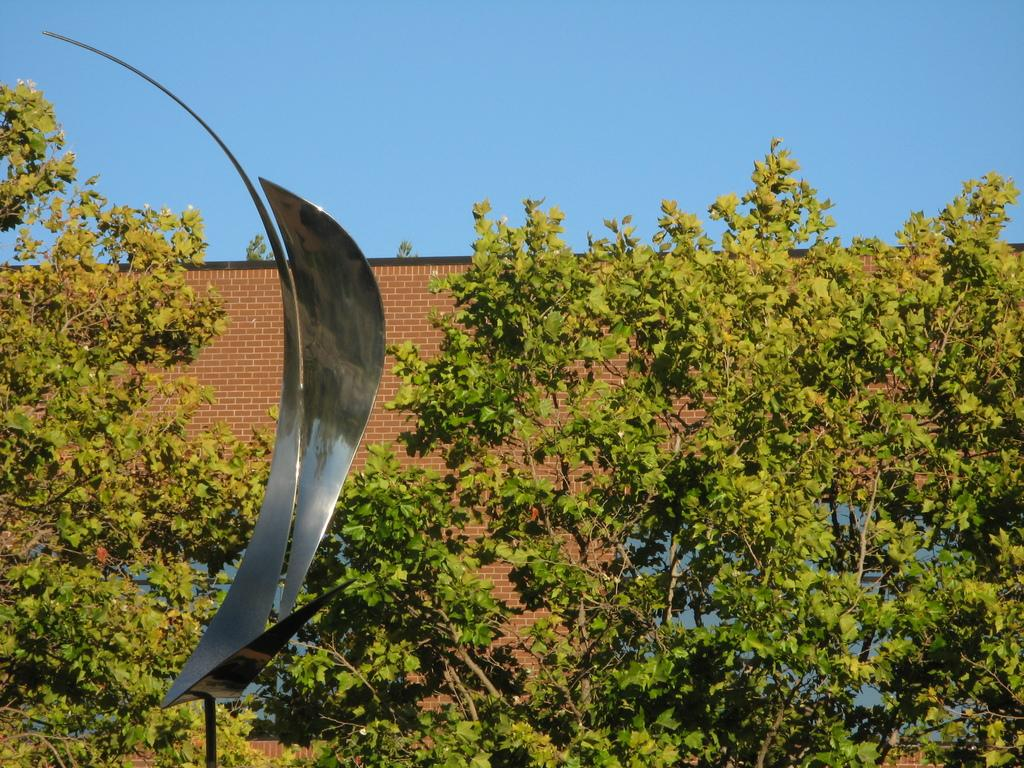What type of structure is visible in the image? There is a brick wall in the image. What type of natural vegetation is present in the image? There are trees in the image. What type of material is used for the metal object in the image? The metal object in the image is made of metal. What is visible in the background of the image? The sky is visible in the image. What type of operation is being performed on the trees in the image? There is no operation being performed on the trees in the image; they are simply standing. What type of veil is covering the brick wall in the image? There is no veil present in the image; the brick wall is visible without any covering. How many rings are visible on the metal object in the image? There are no rings visible on the metal object in the image. 